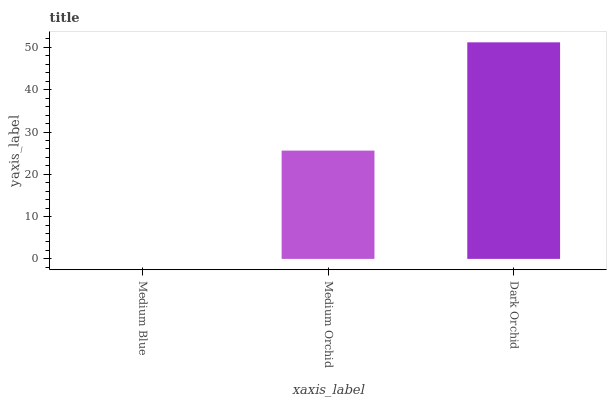Is Medium Blue the minimum?
Answer yes or no. Yes. Is Dark Orchid the maximum?
Answer yes or no. Yes. Is Medium Orchid the minimum?
Answer yes or no. No. Is Medium Orchid the maximum?
Answer yes or no. No. Is Medium Orchid greater than Medium Blue?
Answer yes or no. Yes. Is Medium Blue less than Medium Orchid?
Answer yes or no. Yes. Is Medium Blue greater than Medium Orchid?
Answer yes or no. No. Is Medium Orchid less than Medium Blue?
Answer yes or no. No. Is Medium Orchid the high median?
Answer yes or no. Yes. Is Medium Orchid the low median?
Answer yes or no. Yes. Is Medium Blue the high median?
Answer yes or no. No. Is Medium Blue the low median?
Answer yes or no. No. 